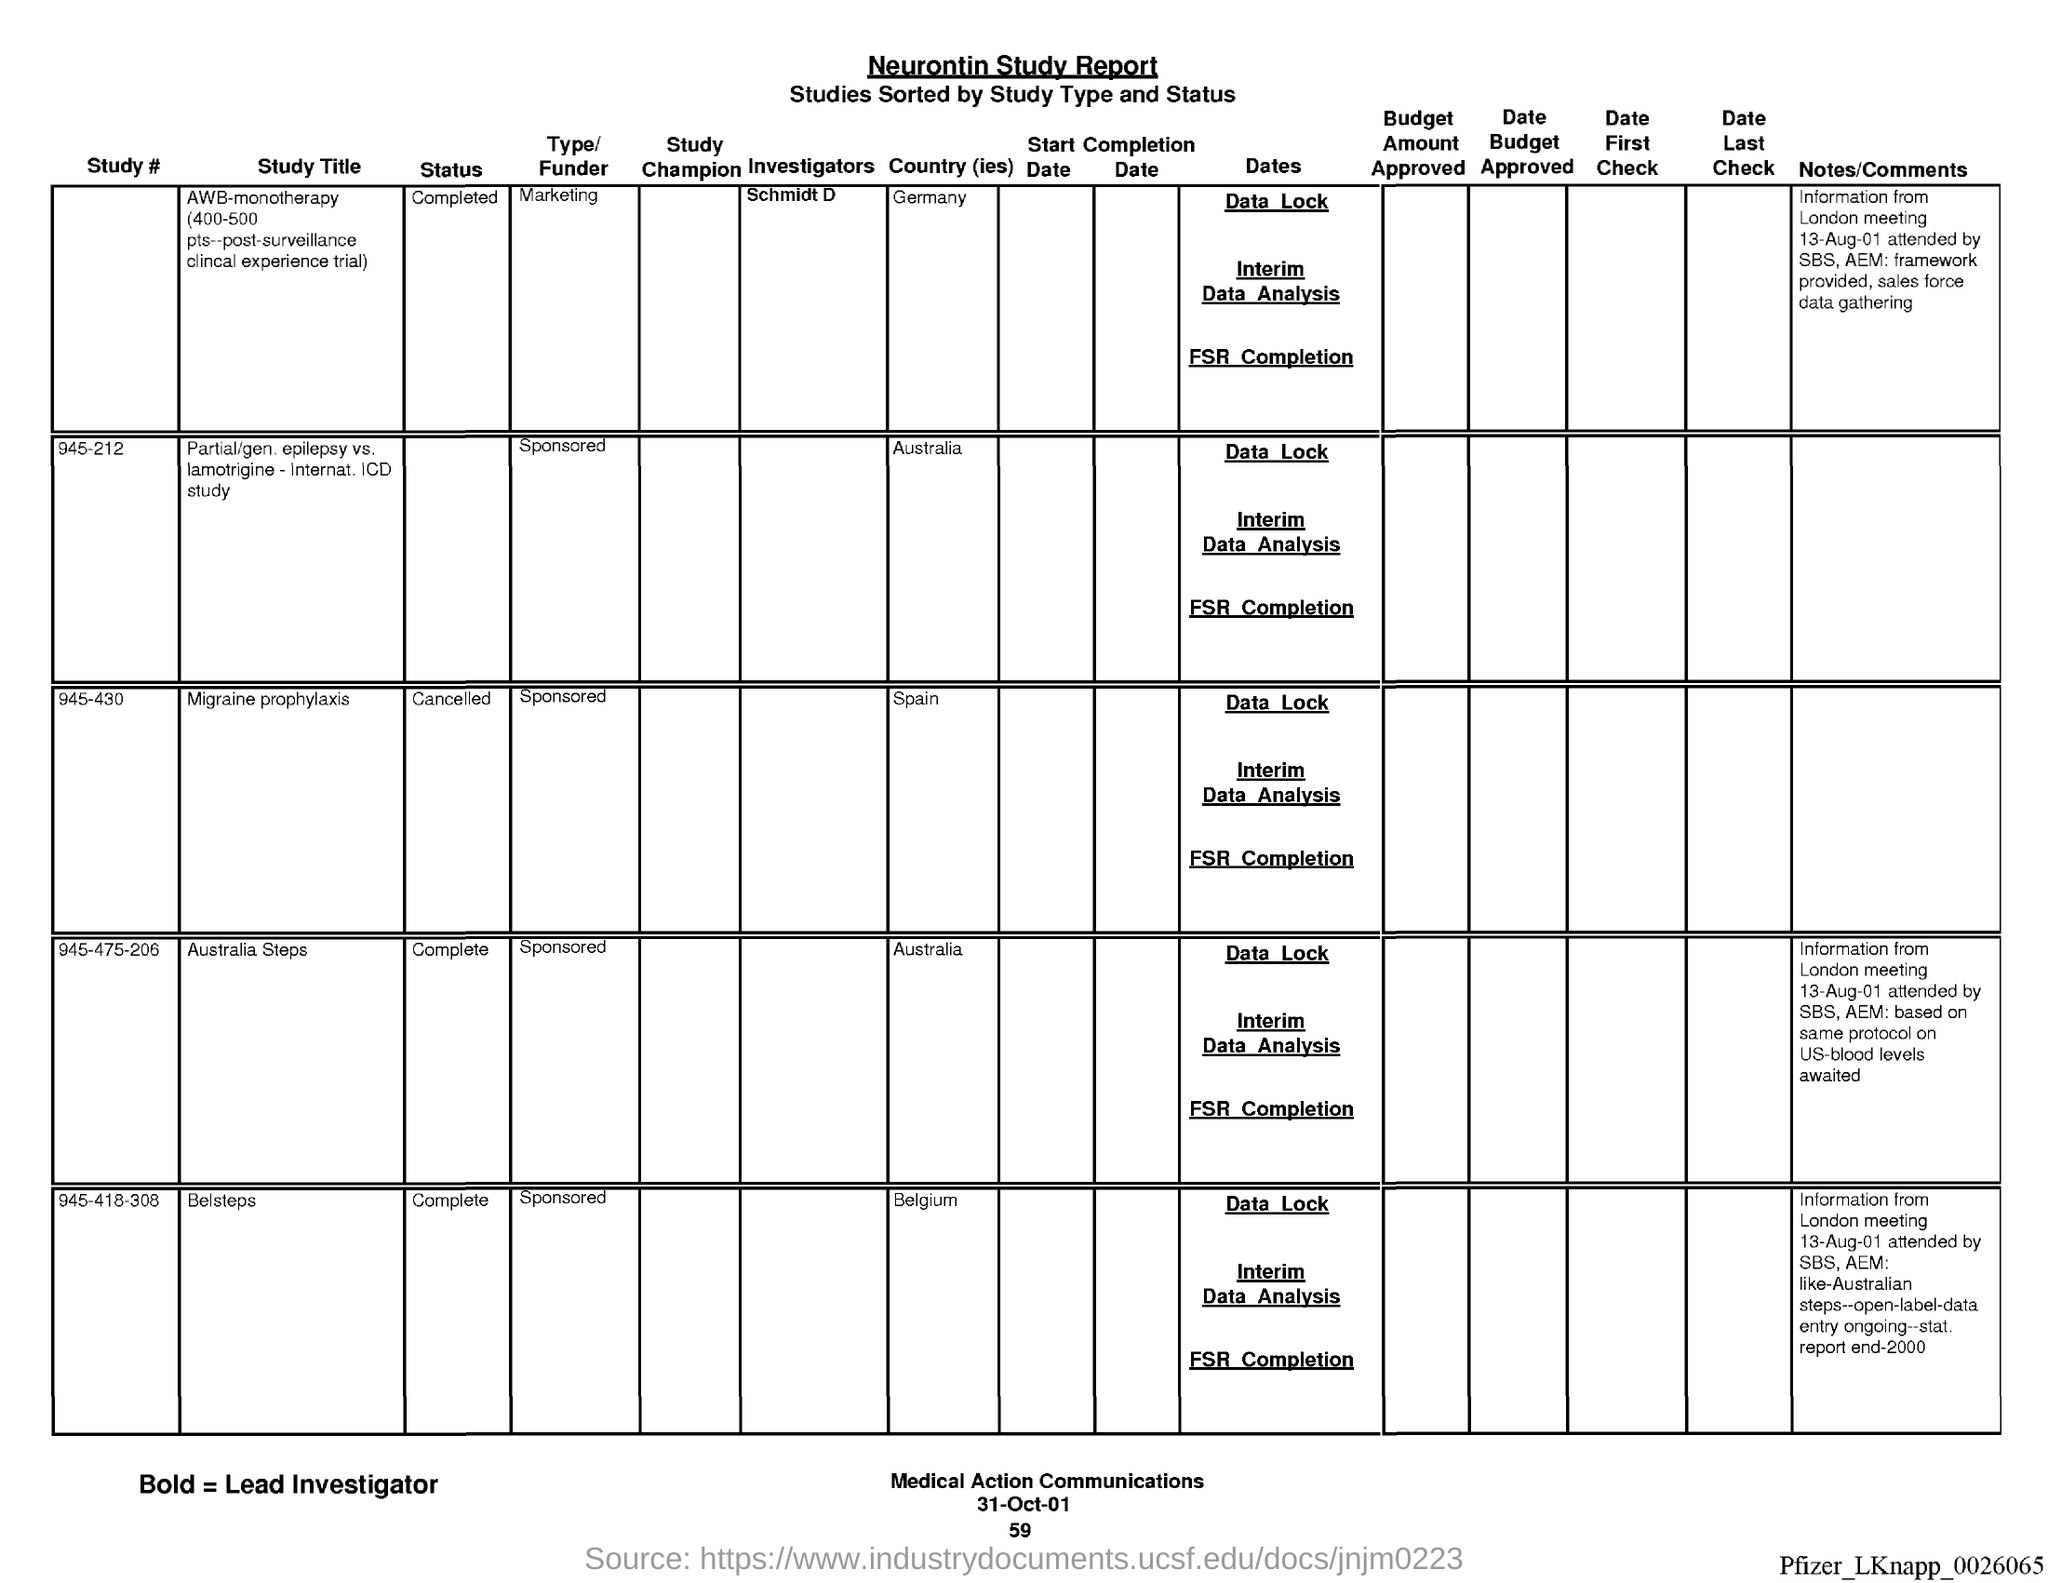What is the name of the report?
Make the answer very short. Neurontin Study report. What is the date at bottom of the page?
Provide a succinct answer. 31-oct-01. What is the page number below date?
Your answer should be compact. 59. 